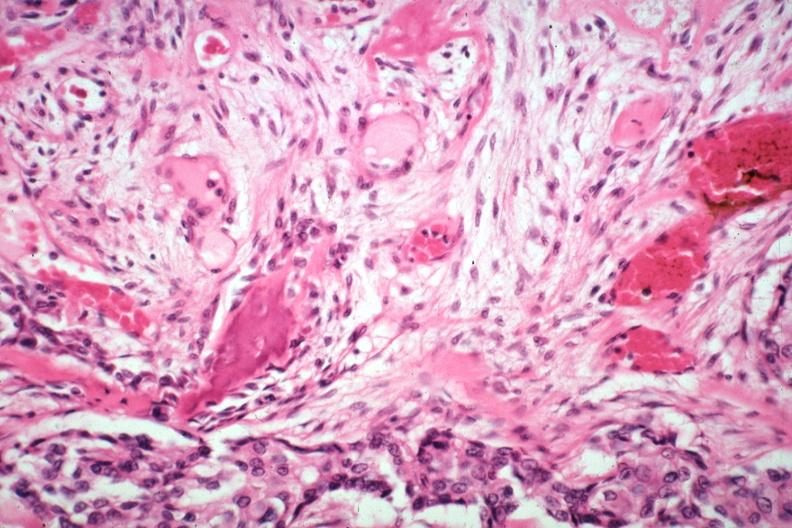what is additional 3194 and?
Answer the question using a single word or phrase. New bone formation excellent depiction large myofibroblastic osteoblastic cells induced by tumor tumor also seen gross 